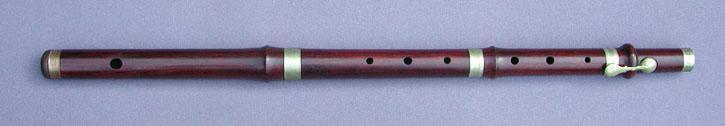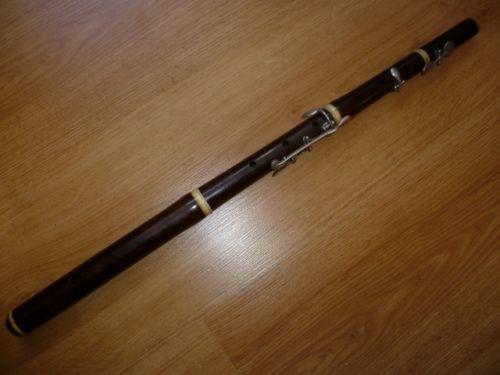The first image is the image on the left, the second image is the image on the right. Examine the images to the left and right. Is the description "The instrument on the left is horizontal, the one on the right is diagonal." accurate? Answer yes or no. Yes. The first image is the image on the left, the second image is the image on the right. Given the left and right images, does the statement "A flute is oriented vertically." hold true? Answer yes or no. No. 